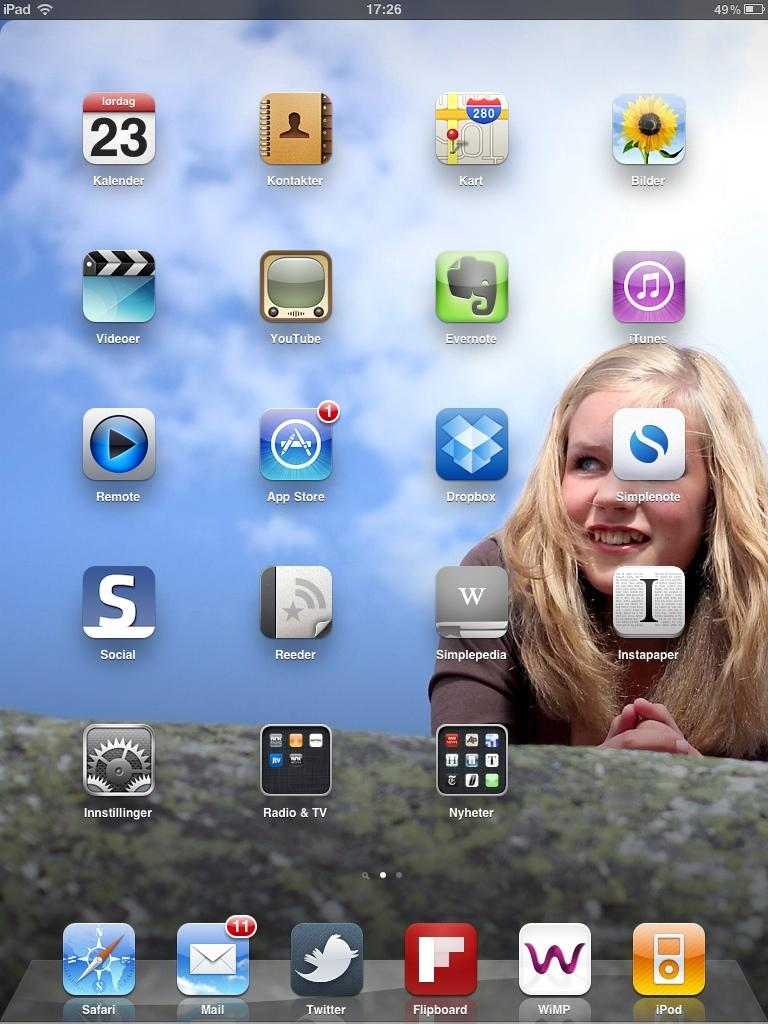<image>
Share a concise interpretation of the image provided. The dropbox app is located next to the App Store app 